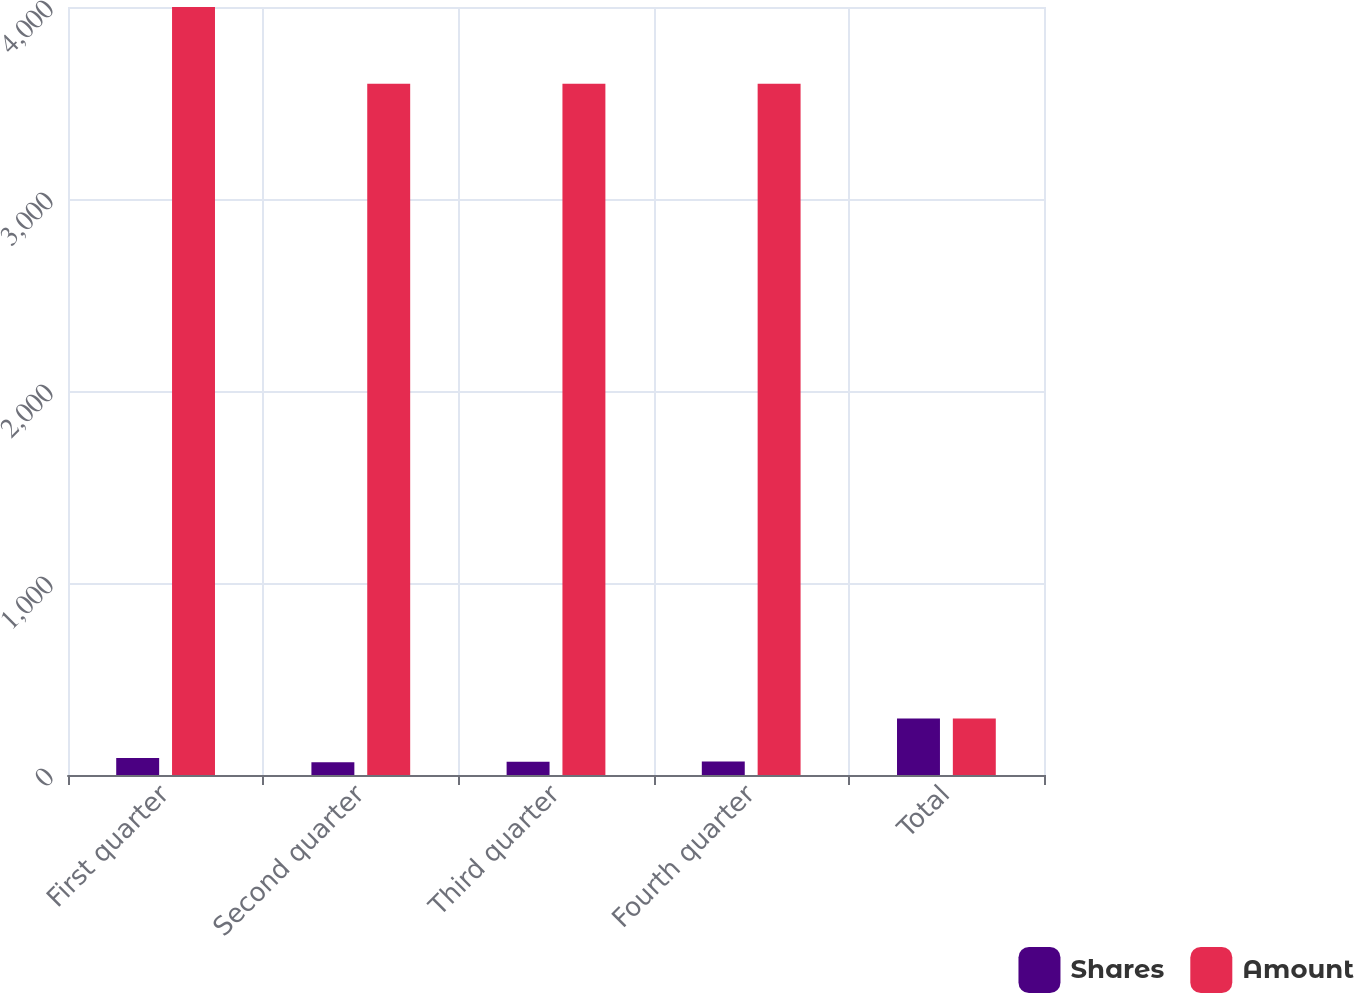Convert chart. <chart><loc_0><loc_0><loc_500><loc_500><stacked_bar_chart><ecel><fcel>First quarter<fcel>Second quarter<fcel>Third quarter<fcel>Fourth quarter<fcel>Total<nl><fcel>Shares<fcel>89<fcel>66<fcel>69<fcel>70<fcel>294<nl><fcel>Amount<fcel>4000<fcel>3600<fcel>3600<fcel>3600<fcel>294<nl></chart> 